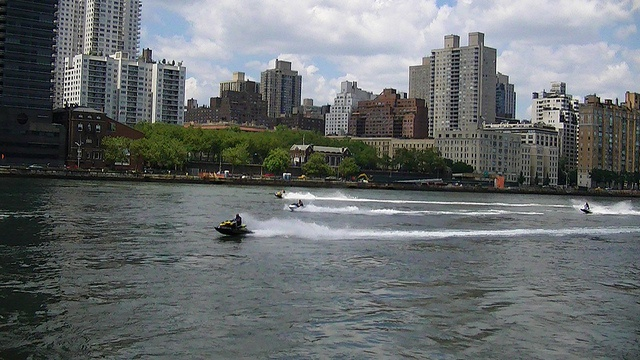Describe the objects in this image and their specific colors. I can see boat in black, gray, darkgreen, and darkgray tones, boat in black, lightgray, gray, and darkgray tones, boat in black, lightgray, and gray tones, people in black, purple, and gray tones, and people in black, darkgray, gray, and olive tones in this image. 